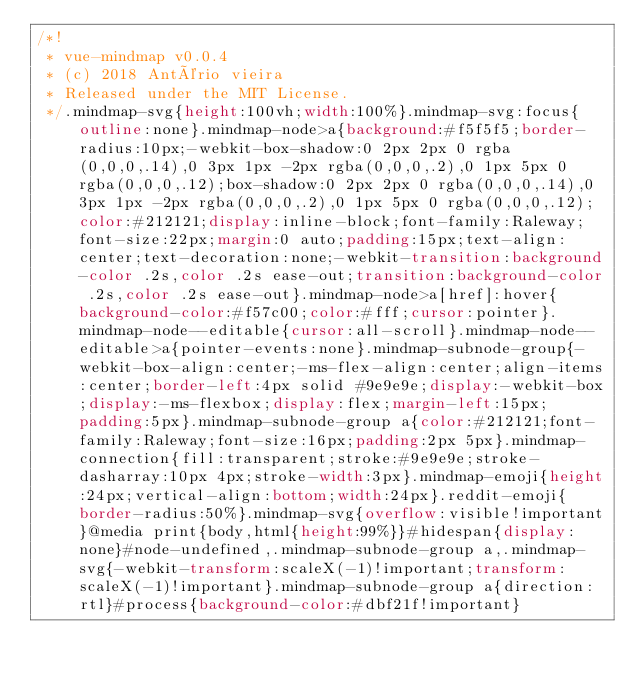Convert code to text. <code><loc_0><loc_0><loc_500><loc_500><_CSS_>/*!
 * vue-mindmap v0.0.4
 * (c) 2018 Antério vieira
 * Released under the MIT License.
 */.mindmap-svg{height:100vh;width:100%}.mindmap-svg:focus{outline:none}.mindmap-node>a{background:#f5f5f5;border-radius:10px;-webkit-box-shadow:0 2px 2px 0 rgba(0,0,0,.14),0 3px 1px -2px rgba(0,0,0,.2),0 1px 5px 0 rgba(0,0,0,.12);box-shadow:0 2px 2px 0 rgba(0,0,0,.14),0 3px 1px -2px rgba(0,0,0,.2),0 1px 5px 0 rgba(0,0,0,.12);color:#212121;display:inline-block;font-family:Raleway;font-size:22px;margin:0 auto;padding:15px;text-align:center;text-decoration:none;-webkit-transition:background-color .2s,color .2s ease-out;transition:background-color .2s,color .2s ease-out}.mindmap-node>a[href]:hover{background-color:#f57c00;color:#fff;cursor:pointer}.mindmap-node--editable{cursor:all-scroll}.mindmap-node--editable>a{pointer-events:none}.mindmap-subnode-group{-webkit-box-align:center;-ms-flex-align:center;align-items:center;border-left:4px solid #9e9e9e;display:-webkit-box;display:-ms-flexbox;display:flex;margin-left:15px;padding:5px}.mindmap-subnode-group a{color:#212121;font-family:Raleway;font-size:16px;padding:2px 5px}.mindmap-connection{fill:transparent;stroke:#9e9e9e;stroke-dasharray:10px 4px;stroke-width:3px}.mindmap-emoji{height:24px;vertical-align:bottom;width:24px}.reddit-emoji{border-radius:50%}.mindmap-svg{overflow:visible!important}@media print{body,html{height:99%}}#hidespan{display:none}#node-undefined,.mindmap-subnode-group a,.mindmap-svg{-webkit-transform:scaleX(-1)!important;transform:scaleX(-1)!important}.mindmap-subnode-group a{direction:rtl}#process{background-color:#dbf21f!important}</code> 